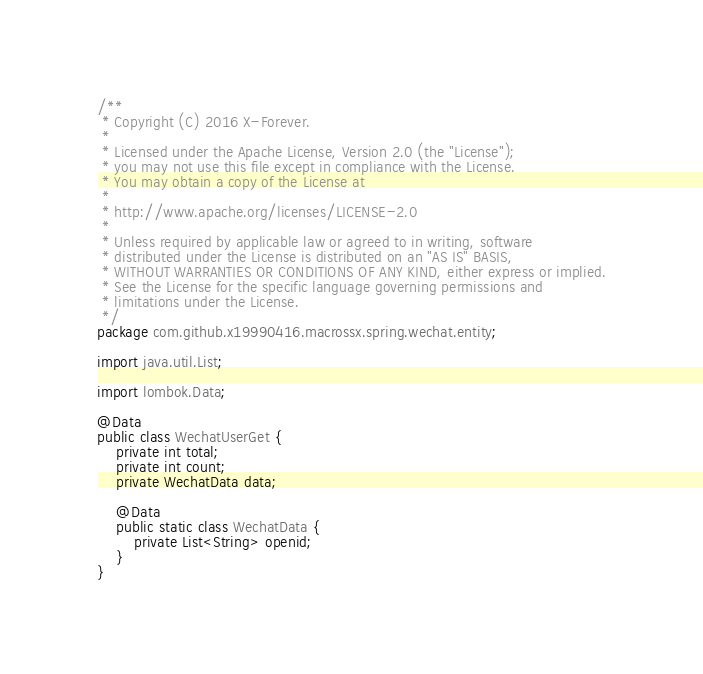Convert code to text. <code><loc_0><loc_0><loc_500><loc_500><_Java_>/**
 * Copyright (C) 2016 X-Forever.
 *
 * Licensed under the Apache License, Version 2.0 (the "License");
 * you may not use this file except in compliance with the License.
 * You may obtain a copy of the License at
 *
 * http://www.apache.org/licenses/LICENSE-2.0
 *
 * Unless required by applicable law or agreed to in writing, software
 * distributed under the License is distributed on an "AS IS" BASIS,
 * WITHOUT WARRANTIES OR CONDITIONS OF ANY KIND, either express or implied.
 * See the License for the specific language governing permissions and
 * limitations under the License.
 */
package com.github.x19990416.macrossx.spring.wechat.entity;

import java.util.List;

import lombok.Data;

@Data
public class WechatUserGet {
	private int total;
	private int count;
	private WechatData data;

	@Data
	public static class WechatData {
		private List<String> openid;
	}
}
</code> 